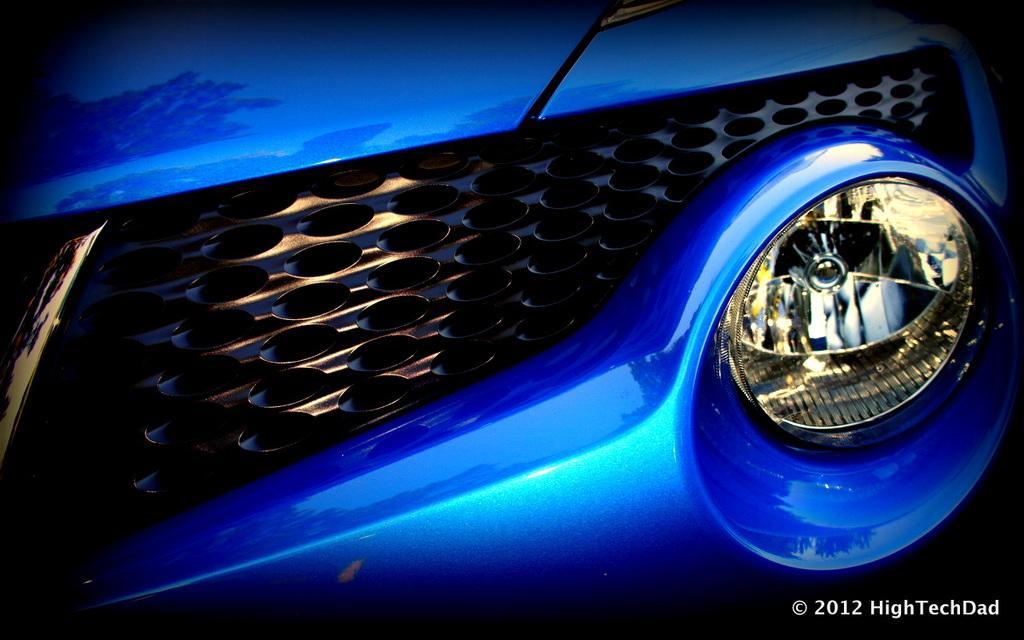In one or two sentences, can you explain what this image depicts? In this picture we can see grille and headlight. In the bottom right side of the image we can see text and year. 